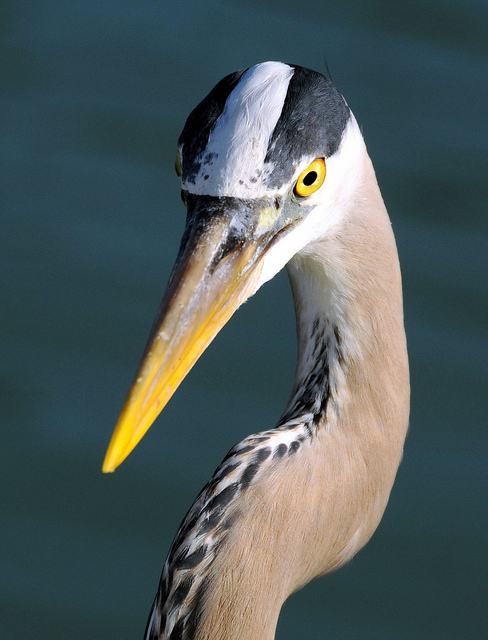What do Grey Herons typically eat? Grey Herons feed primarily on a wide variety of aquatic organisms including fish, crustaceans, and small insects. They are known for their patient hunting technique, standing still for long periods to catch prey in the water. 